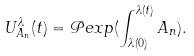Convert formula to latex. <formula><loc_0><loc_0><loc_500><loc_500>U ^ { \lambda } _ { A _ { n } } ( t ) = \mathcal { P } e x p ( \int _ { \lambda ( 0 ) } ^ { \lambda ( t ) } A _ { n } ) .</formula> 